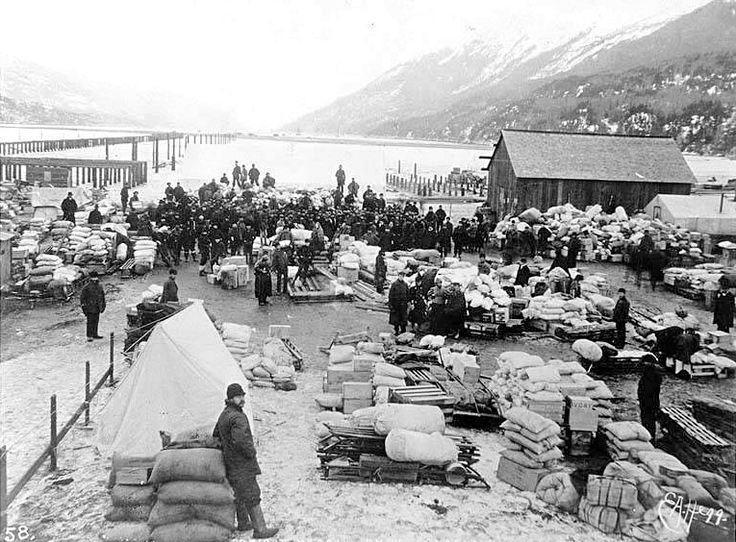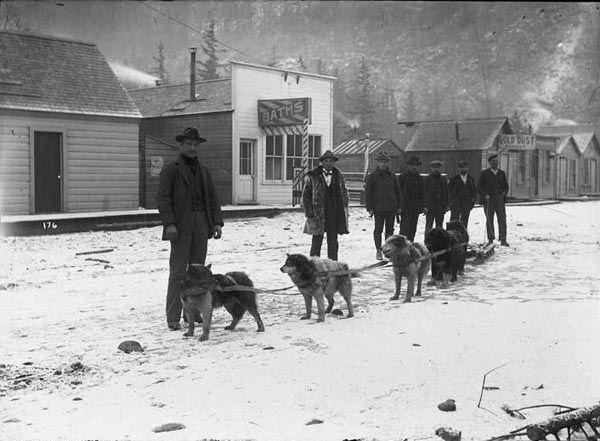The first image is the image on the left, the second image is the image on the right. For the images displayed, is the sentence "A pack of dogs is standing in the snow near a building in the image on the left." factually correct? Answer yes or no. No. The first image is the image on the left, the second image is the image on the right. Considering the images on both sides, is "One image shows a team of rope-hitched dogs resting on the snow, with no sled or any landmarks in sight and with at least some dogs reclining." valid? Answer yes or no. No. 